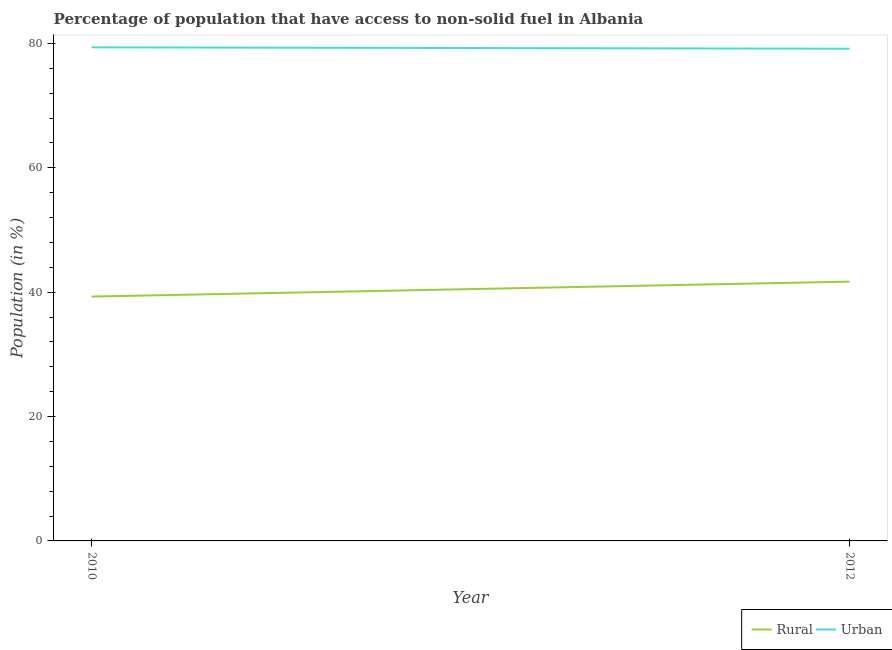Does the line corresponding to urban population intersect with the line corresponding to rural population?
Ensure brevity in your answer.  No. What is the rural population in 2012?
Make the answer very short. 41.7. Across all years, what is the maximum urban population?
Offer a terse response. 79.37. Across all years, what is the minimum urban population?
Give a very brief answer. 79.15. In which year was the urban population maximum?
Offer a very short reply. 2010. In which year was the urban population minimum?
Your answer should be compact. 2012. What is the total urban population in the graph?
Your response must be concise. 158.52. What is the difference between the rural population in 2010 and that in 2012?
Provide a short and direct response. -2.4. What is the difference between the rural population in 2012 and the urban population in 2010?
Ensure brevity in your answer.  -37.68. What is the average rural population per year?
Offer a terse response. 40.5. In the year 2010, what is the difference between the urban population and rural population?
Offer a very short reply. 40.08. What is the ratio of the urban population in 2010 to that in 2012?
Keep it short and to the point. 1. Is the rural population in 2010 less than that in 2012?
Provide a succinct answer. Yes. In how many years, is the rural population greater than the average rural population taken over all years?
Provide a succinct answer. 1. Does the rural population monotonically increase over the years?
Make the answer very short. Yes. Is the rural population strictly less than the urban population over the years?
Give a very brief answer. Yes. Are the values on the major ticks of Y-axis written in scientific E-notation?
Offer a very short reply. No. Does the graph contain any zero values?
Offer a terse response. No. Does the graph contain grids?
Provide a succinct answer. No. What is the title of the graph?
Keep it short and to the point. Percentage of population that have access to non-solid fuel in Albania. What is the label or title of the Y-axis?
Ensure brevity in your answer.  Population (in %). What is the Population (in %) in Rural in 2010?
Make the answer very short. 39.29. What is the Population (in %) in Urban in 2010?
Ensure brevity in your answer.  79.37. What is the Population (in %) in Rural in 2012?
Keep it short and to the point. 41.7. What is the Population (in %) in Urban in 2012?
Make the answer very short. 79.15. Across all years, what is the maximum Population (in %) of Rural?
Make the answer very short. 41.7. Across all years, what is the maximum Population (in %) in Urban?
Ensure brevity in your answer.  79.37. Across all years, what is the minimum Population (in %) of Rural?
Your answer should be very brief. 39.29. Across all years, what is the minimum Population (in %) of Urban?
Your answer should be very brief. 79.15. What is the total Population (in %) in Rural in the graph?
Offer a very short reply. 80.99. What is the total Population (in %) of Urban in the graph?
Offer a terse response. 158.52. What is the difference between the Population (in %) in Rural in 2010 and that in 2012?
Provide a succinct answer. -2.4. What is the difference between the Population (in %) in Urban in 2010 and that in 2012?
Offer a terse response. 0.23. What is the difference between the Population (in %) in Rural in 2010 and the Population (in %) in Urban in 2012?
Your answer should be compact. -39.85. What is the average Population (in %) in Rural per year?
Your response must be concise. 40.5. What is the average Population (in %) in Urban per year?
Keep it short and to the point. 79.26. In the year 2010, what is the difference between the Population (in %) of Rural and Population (in %) of Urban?
Ensure brevity in your answer.  -40.08. In the year 2012, what is the difference between the Population (in %) in Rural and Population (in %) in Urban?
Your answer should be compact. -37.45. What is the ratio of the Population (in %) in Rural in 2010 to that in 2012?
Provide a succinct answer. 0.94. What is the difference between the highest and the second highest Population (in %) of Rural?
Offer a terse response. 2.4. What is the difference between the highest and the second highest Population (in %) of Urban?
Ensure brevity in your answer.  0.23. What is the difference between the highest and the lowest Population (in %) of Rural?
Keep it short and to the point. 2.4. What is the difference between the highest and the lowest Population (in %) in Urban?
Provide a short and direct response. 0.23. 